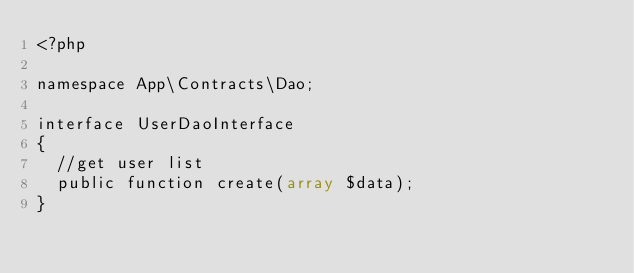<code> <loc_0><loc_0><loc_500><loc_500><_PHP_><?php

namespace App\Contracts\Dao;

interface UserDaoInterface
{
  //get user list
  public function create(array $data);
}</code> 